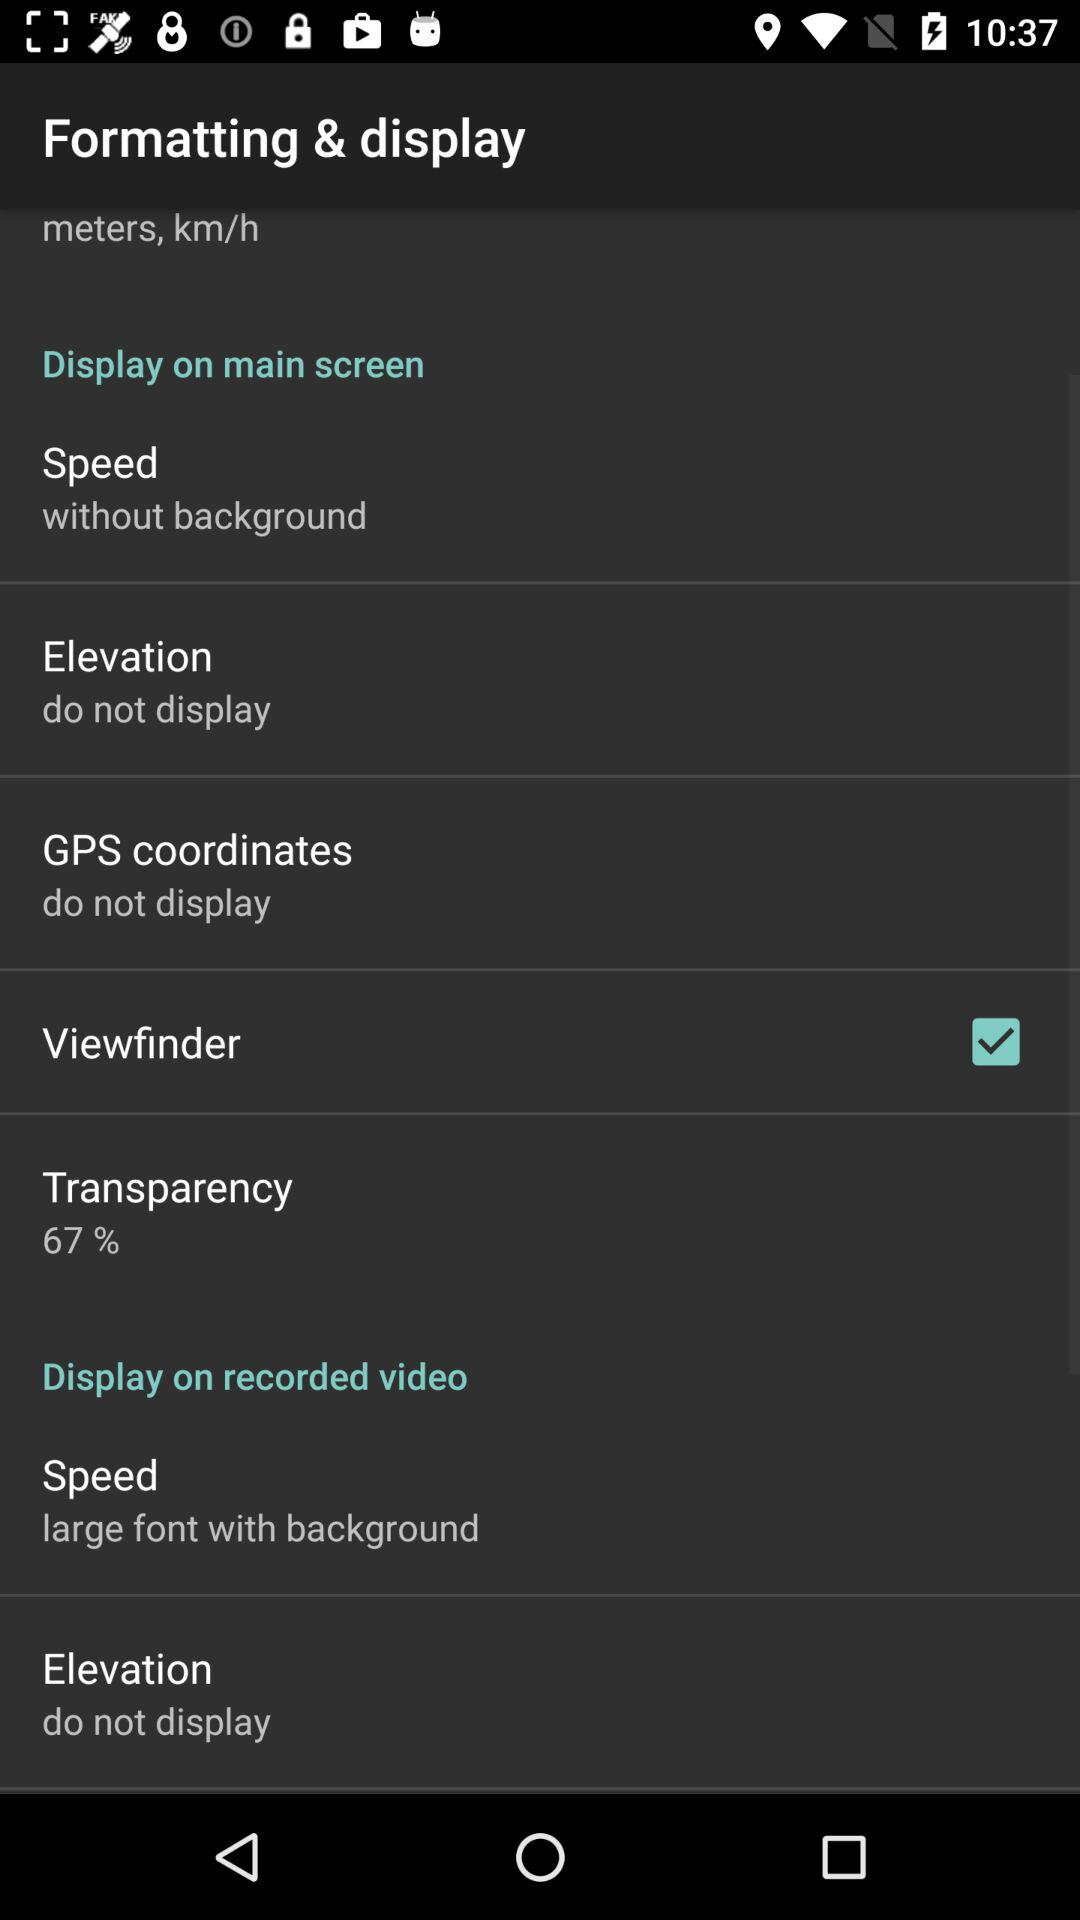What percent of transparency is there? The transparency is 67%. 